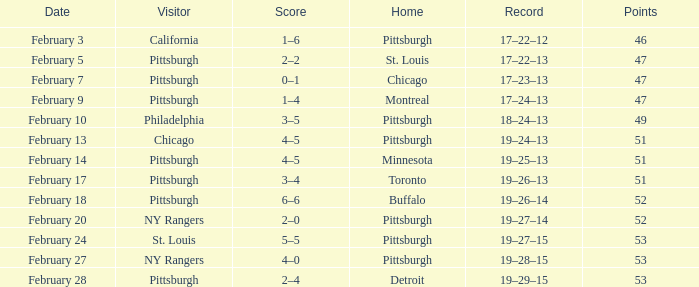Which Score has a Visitor of ny rangers, and a Record of 19–28–15? 4–0. 